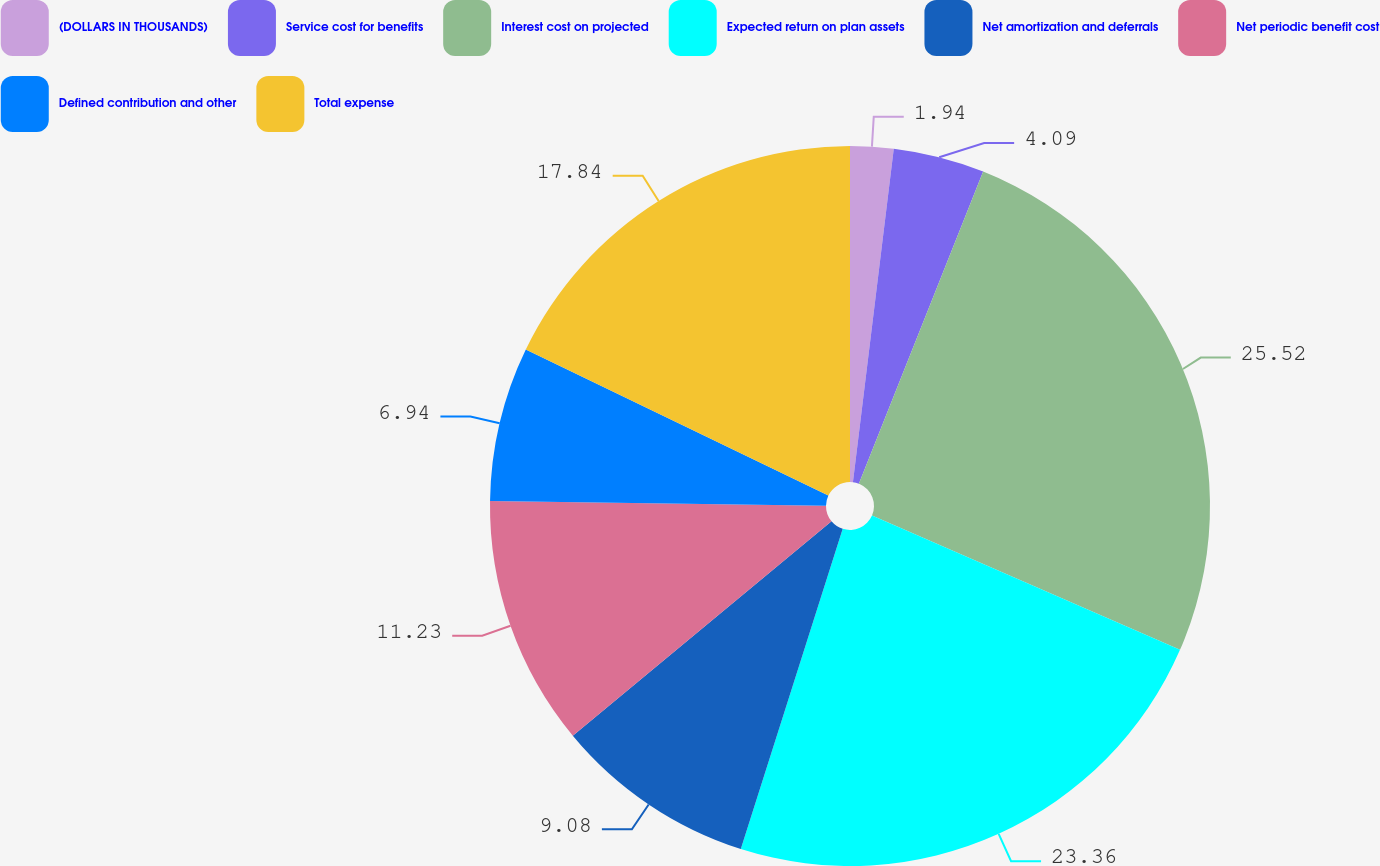Convert chart to OTSL. <chart><loc_0><loc_0><loc_500><loc_500><pie_chart><fcel>(DOLLARS IN THOUSANDS)<fcel>Service cost for benefits<fcel>Interest cost on projected<fcel>Expected return on plan assets<fcel>Net amortization and deferrals<fcel>Net periodic benefit cost<fcel>Defined contribution and other<fcel>Total expense<nl><fcel>1.94%<fcel>4.09%<fcel>25.51%<fcel>23.36%<fcel>9.08%<fcel>11.23%<fcel>6.94%<fcel>17.84%<nl></chart> 